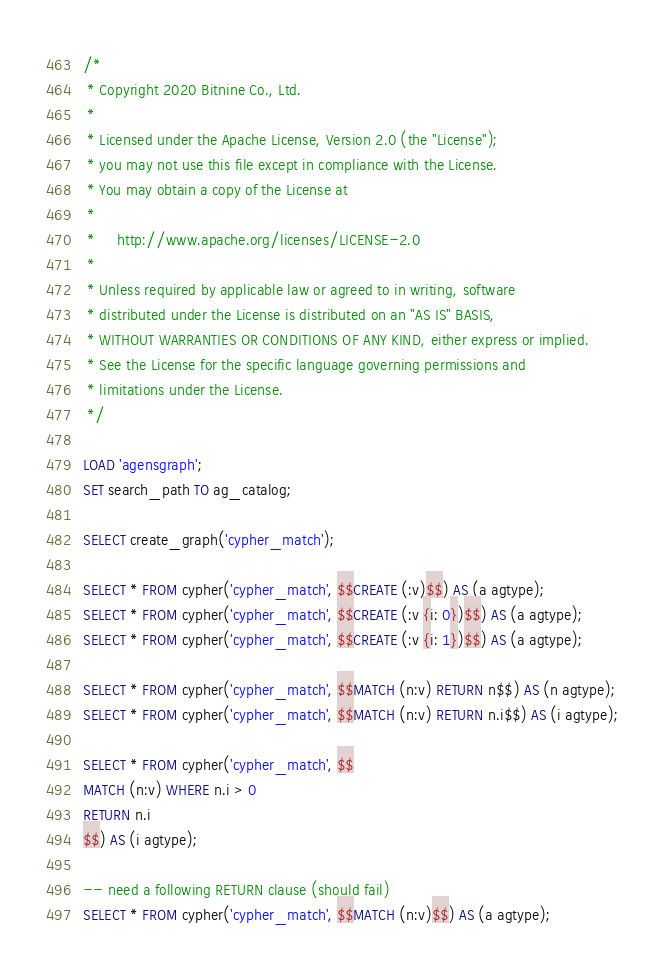Convert code to text. <code><loc_0><loc_0><loc_500><loc_500><_SQL_>/*
 * Copyright 2020 Bitnine Co., Ltd.
 *
 * Licensed under the Apache License, Version 2.0 (the "License");
 * you may not use this file except in compliance with the License.
 * You may obtain a copy of the License at
 *
 *     http://www.apache.org/licenses/LICENSE-2.0
 *
 * Unless required by applicable law or agreed to in writing, software
 * distributed under the License is distributed on an "AS IS" BASIS,
 * WITHOUT WARRANTIES OR CONDITIONS OF ANY KIND, either express or implied.
 * See the License for the specific language governing permissions and
 * limitations under the License.
 */

LOAD 'agensgraph';
SET search_path TO ag_catalog;

SELECT create_graph('cypher_match');

SELECT * FROM cypher('cypher_match', $$CREATE (:v)$$) AS (a agtype);
SELECT * FROM cypher('cypher_match', $$CREATE (:v {i: 0})$$) AS (a agtype);
SELECT * FROM cypher('cypher_match', $$CREATE (:v {i: 1})$$) AS (a agtype);

SELECT * FROM cypher('cypher_match', $$MATCH (n:v) RETURN n$$) AS (n agtype);
SELECT * FROM cypher('cypher_match', $$MATCH (n:v) RETURN n.i$$) AS (i agtype);

SELECT * FROM cypher('cypher_match', $$
MATCH (n:v) WHERE n.i > 0
RETURN n.i
$$) AS (i agtype);

-- need a following RETURN clause (should fail)
SELECT * FROM cypher('cypher_match', $$MATCH (n:v)$$) AS (a agtype);
</code> 